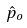<formula> <loc_0><loc_0><loc_500><loc_500>\hat { p } _ { o }</formula> 